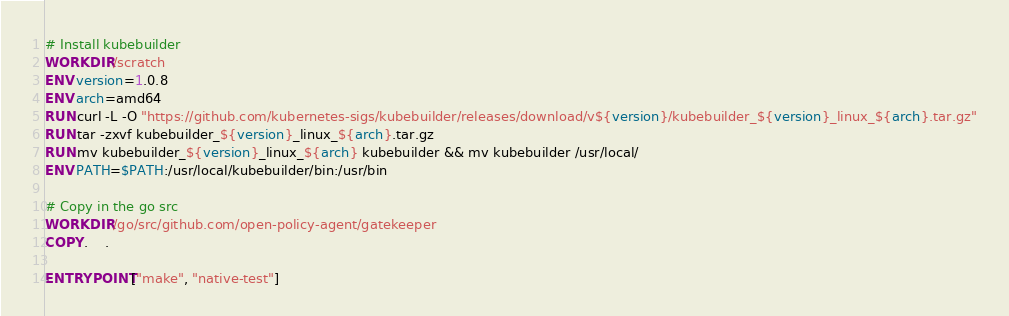Convert code to text. <code><loc_0><loc_0><loc_500><loc_500><_Dockerfile_># Install kubebuilder
WORKDIR /scratch
ENV version=1.0.8
ENV arch=amd64
RUN curl -L -O "https://github.com/kubernetes-sigs/kubebuilder/releases/download/v${version}/kubebuilder_${version}_linux_${arch}.tar.gz"
RUN tar -zxvf kubebuilder_${version}_linux_${arch}.tar.gz
RUN mv kubebuilder_${version}_linux_${arch} kubebuilder && mv kubebuilder /usr/local/
ENV PATH=$PATH:/usr/local/kubebuilder/bin:/usr/bin

# Copy in the go src
WORKDIR /go/src/github.com/open-policy-agent/gatekeeper
COPY .    .

ENTRYPOINT ["make", "native-test"]
</code> 